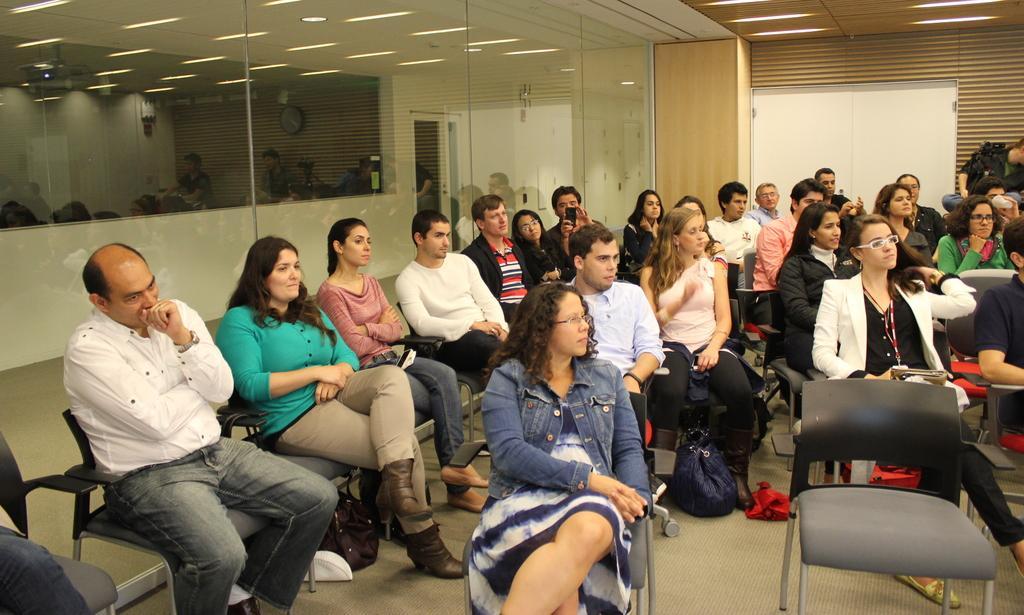Describe this image in one or two sentences. The image is taken in the room. In the center there are many people sitting on the chairs. In the background there is a door. At the top there are lights. 